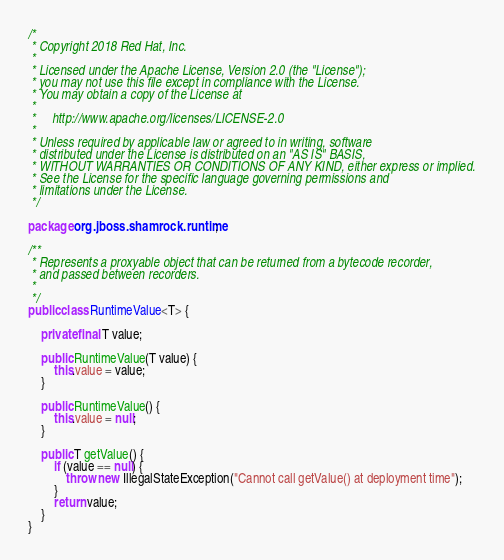Convert code to text. <code><loc_0><loc_0><loc_500><loc_500><_Java_>/*
 * Copyright 2018 Red Hat, Inc.
 *
 * Licensed under the Apache License, Version 2.0 (the "License");
 * you may not use this file except in compliance with the License.
 * You may obtain a copy of the License at
 *
 *     http://www.apache.org/licenses/LICENSE-2.0
 *
 * Unless required by applicable law or agreed to in writing, software
 * distributed under the License is distributed on an "AS IS" BASIS,
 * WITHOUT WARRANTIES OR CONDITIONS OF ANY KIND, either express or implied.
 * See the License for the specific language governing permissions and
 * limitations under the License.
 */

package org.jboss.shamrock.runtime;

/**
 * Represents a proxyable object that can be returned from a bytecode recorder,
 * and passed between recorders.
 *
 */
public class RuntimeValue<T> {

    private final T value;

    public RuntimeValue(T value) {
        this.value = value;
    }

    public RuntimeValue() {
        this.value = null;
    }

    public T getValue() {
        if (value == null) {
            throw new IllegalStateException("Cannot call getValue() at deployment time");
        }
        return value;
    }
}
</code> 